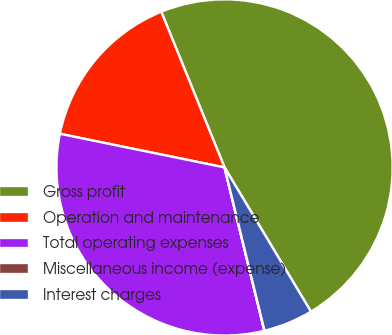Convert chart. <chart><loc_0><loc_0><loc_500><loc_500><pie_chart><fcel>Gross profit<fcel>Operation and maintenance<fcel>Total operating expenses<fcel>Miscellaneous income (expense)<fcel>Interest charges<nl><fcel>47.55%<fcel>15.65%<fcel>32.01%<fcel>0.02%<fcel>4.77%<nl></chart> 